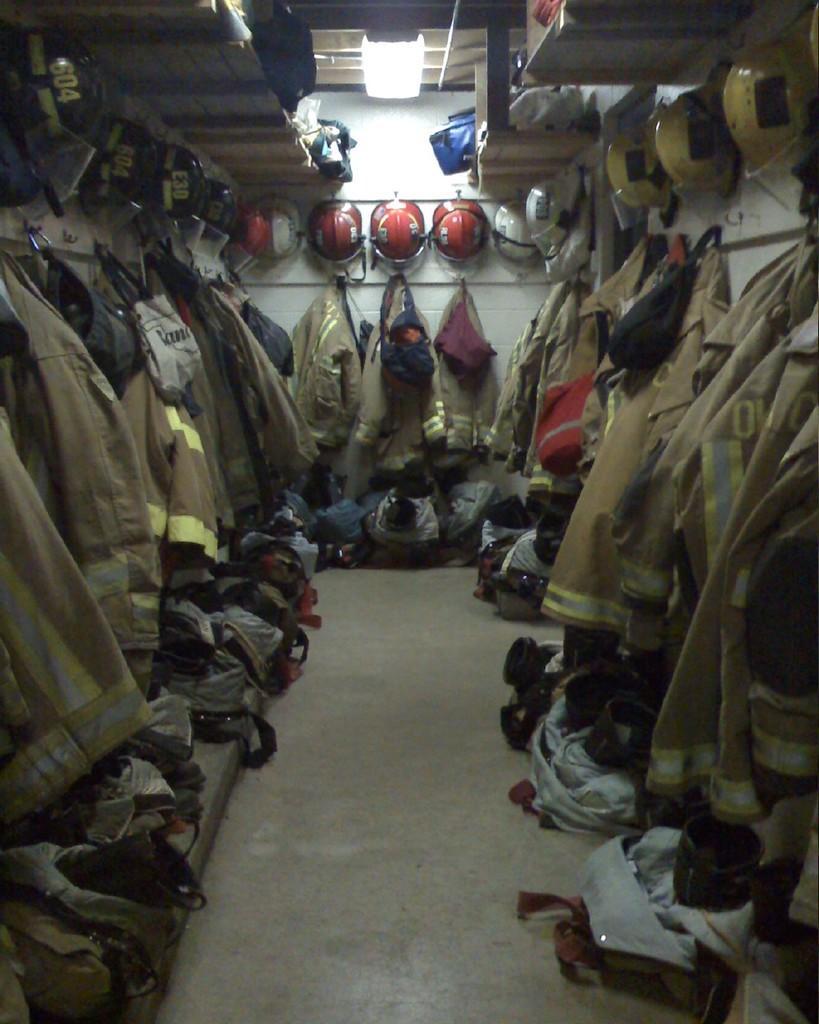Please provide a concise description of this image. In this image there are so many army suits which are hanged to the wall. At the top there are helmets which are kept one beside the other. At the top there is light. Beside the light there is a rack on which there are bags. At the bottom there are bags around the floor. 